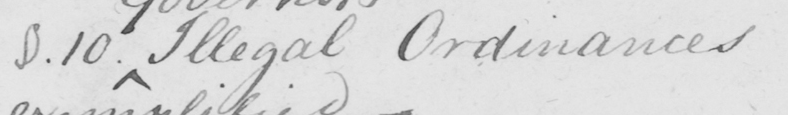Transcribe the text shown in this historical manuscript line. §.10 . Illegal Ordinances 